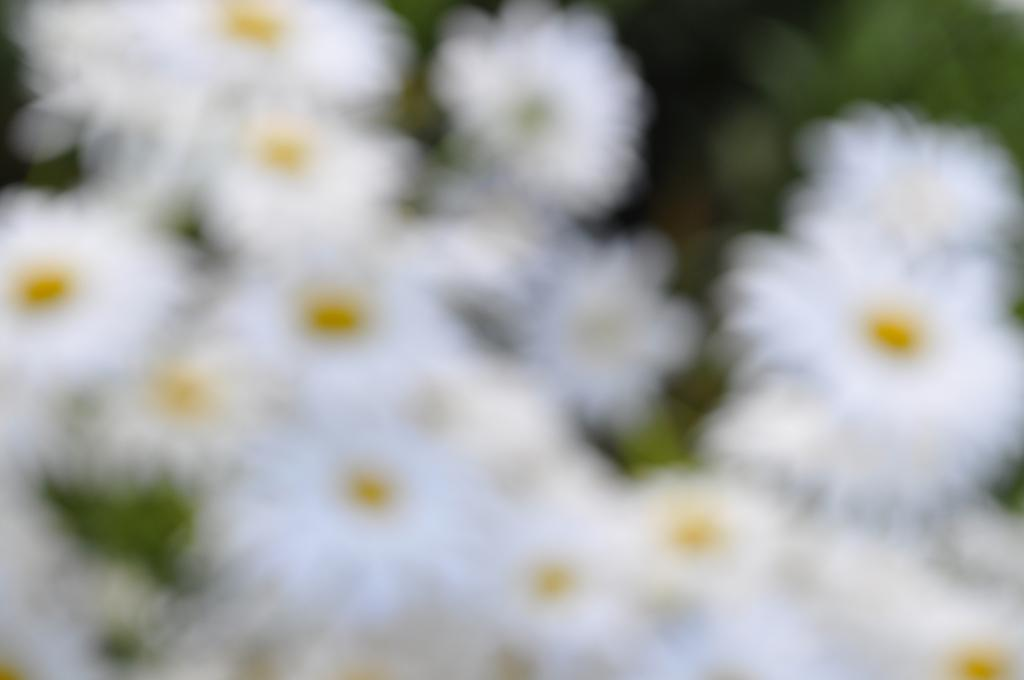What type of flora is present in the image? There are flowers in the image. What colors are the flowers? The flowers are white and yellow in color. What color is the background in the image? The background in the image is green. What type of company is depicted on the canvas in the image? There is no canvas or company present in the image; it features flowers with a green background. 